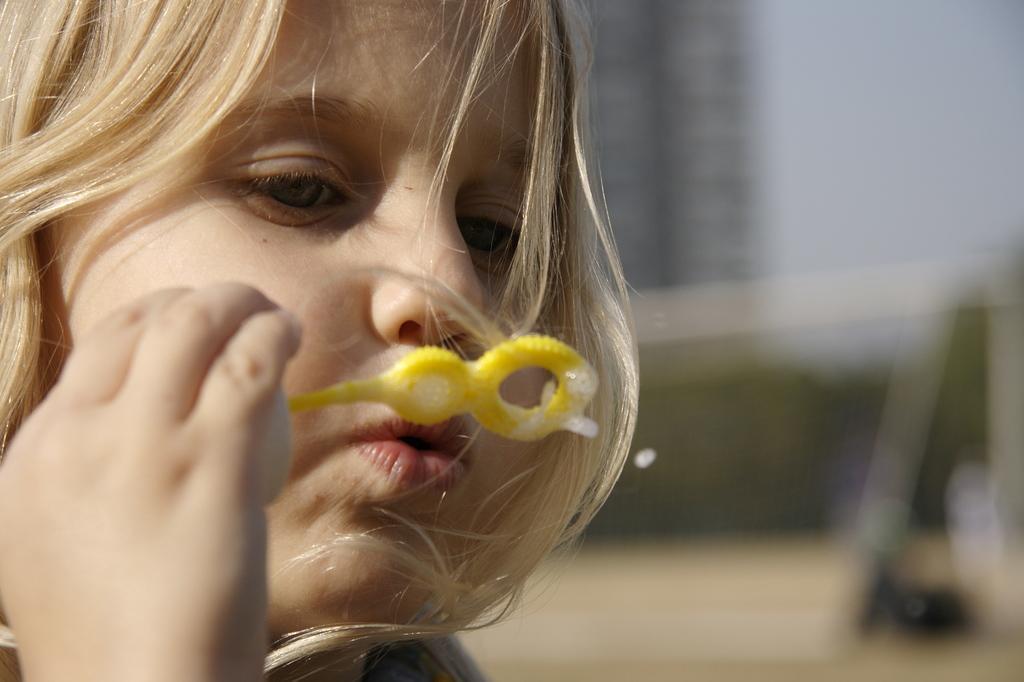In one or two sentences, can you explain what this image depicts? In this picture we can observe a girl. She is blowing soap bubbles. We can observe cream color hair. The background is completely blurred. 